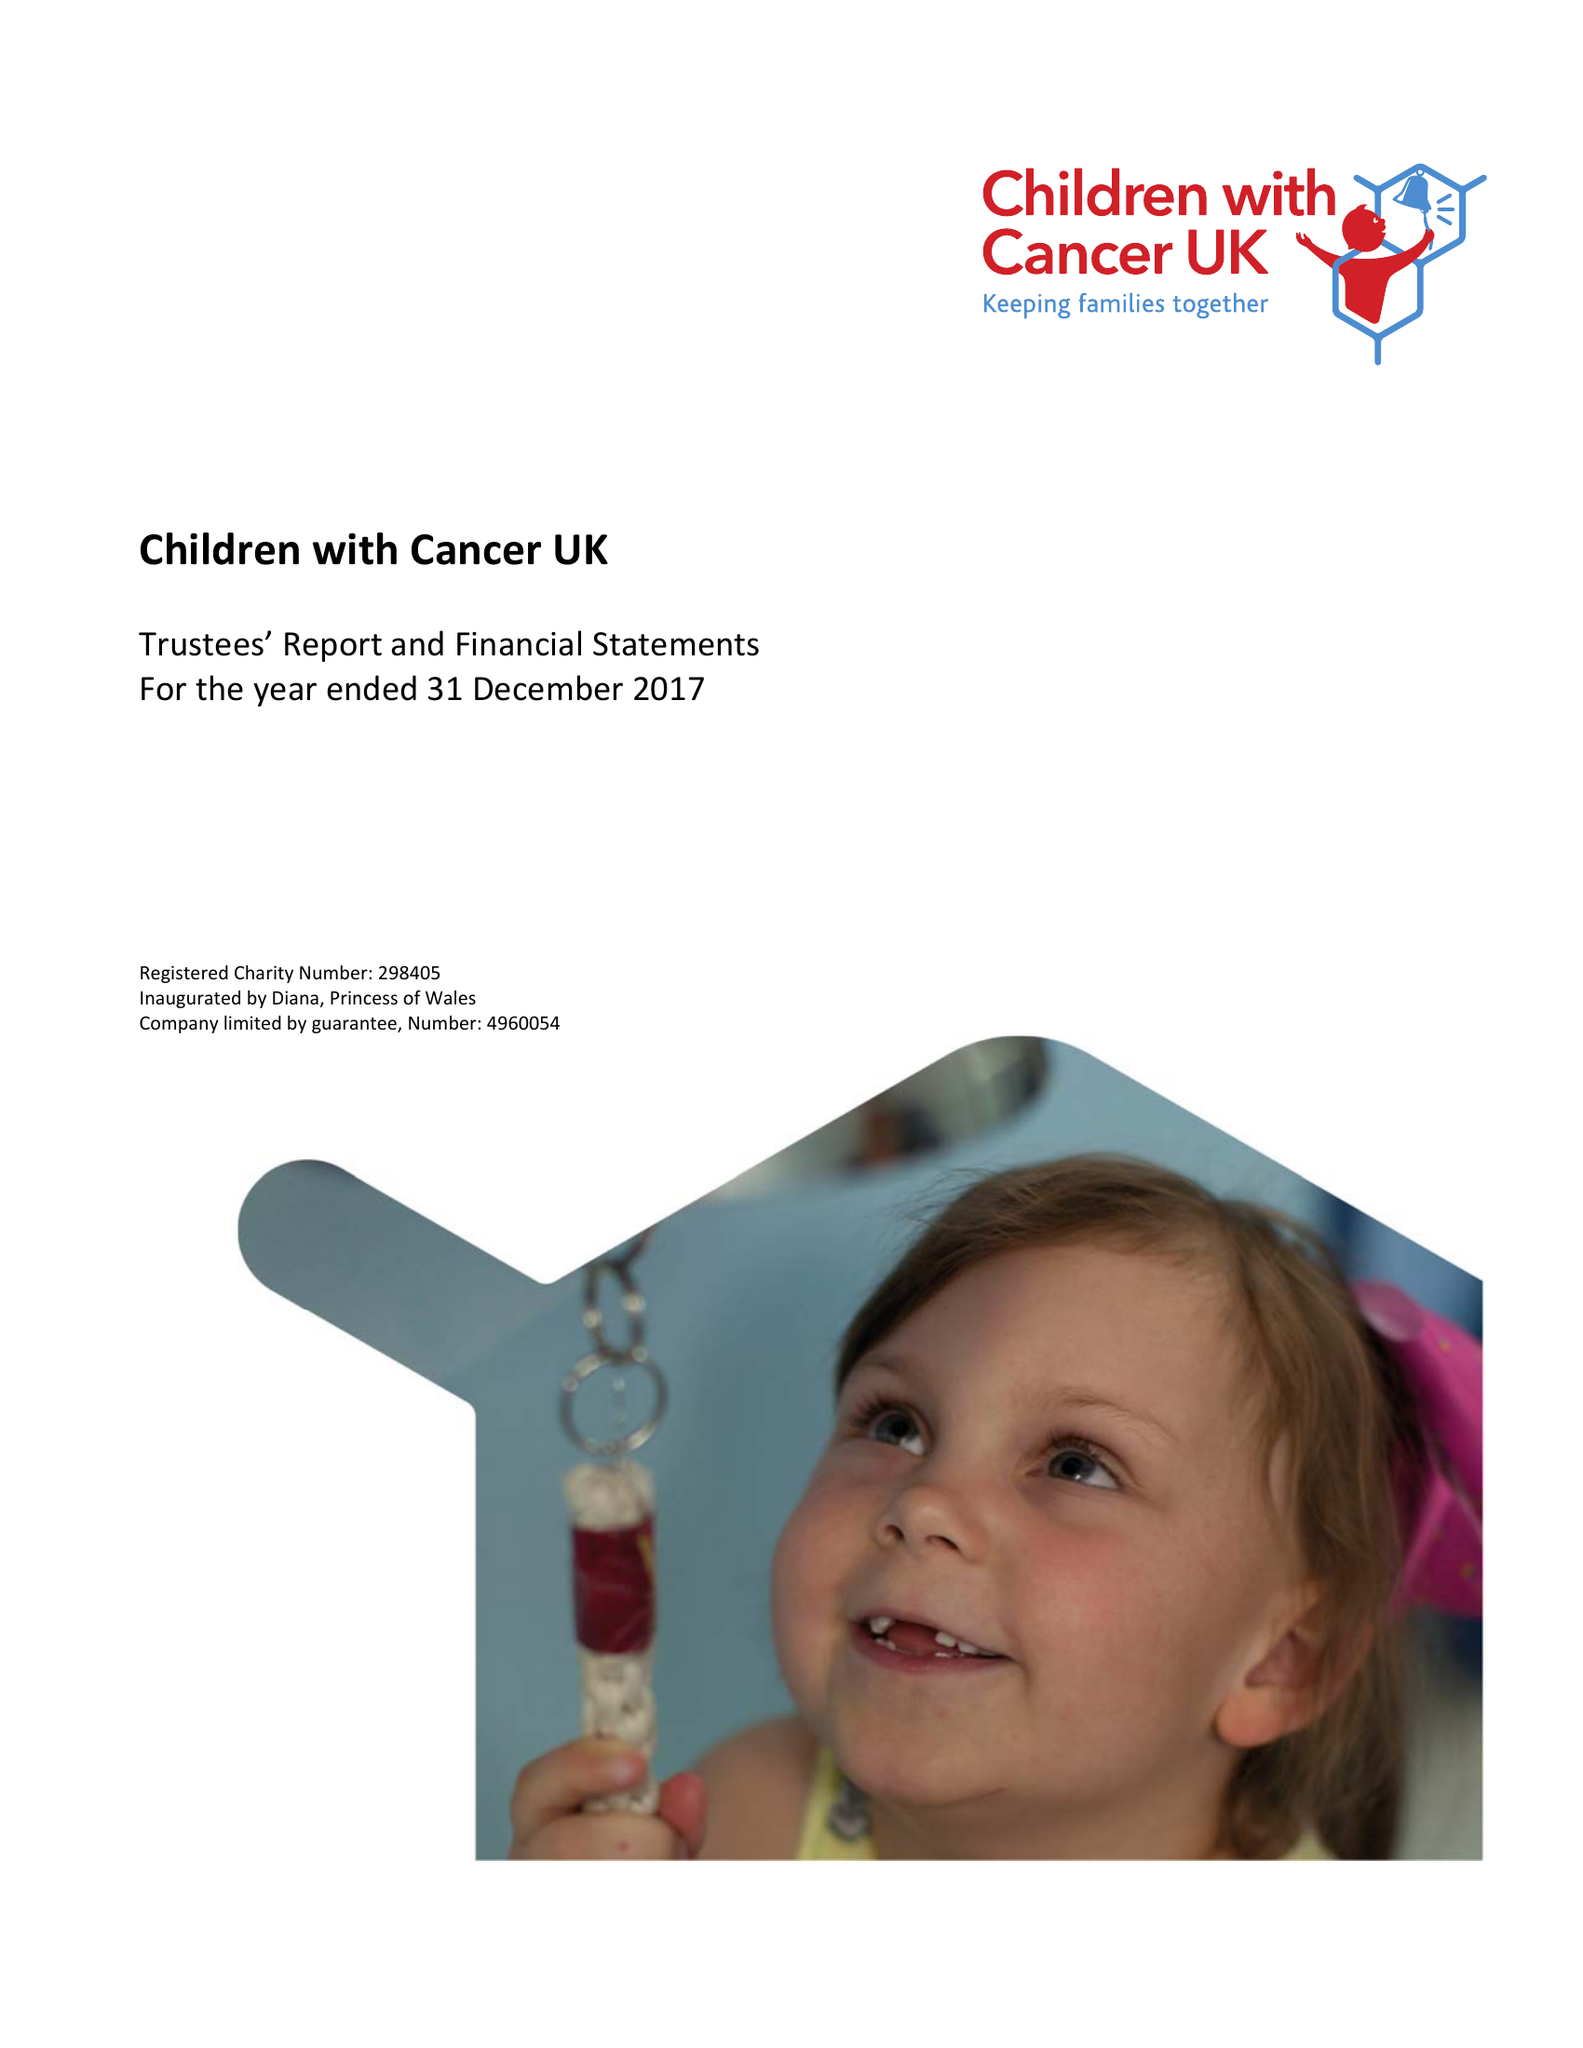What is the value for the address__street_line?
Answer the question using a single word or phrase. 51 GREAT ORMOND STREET 